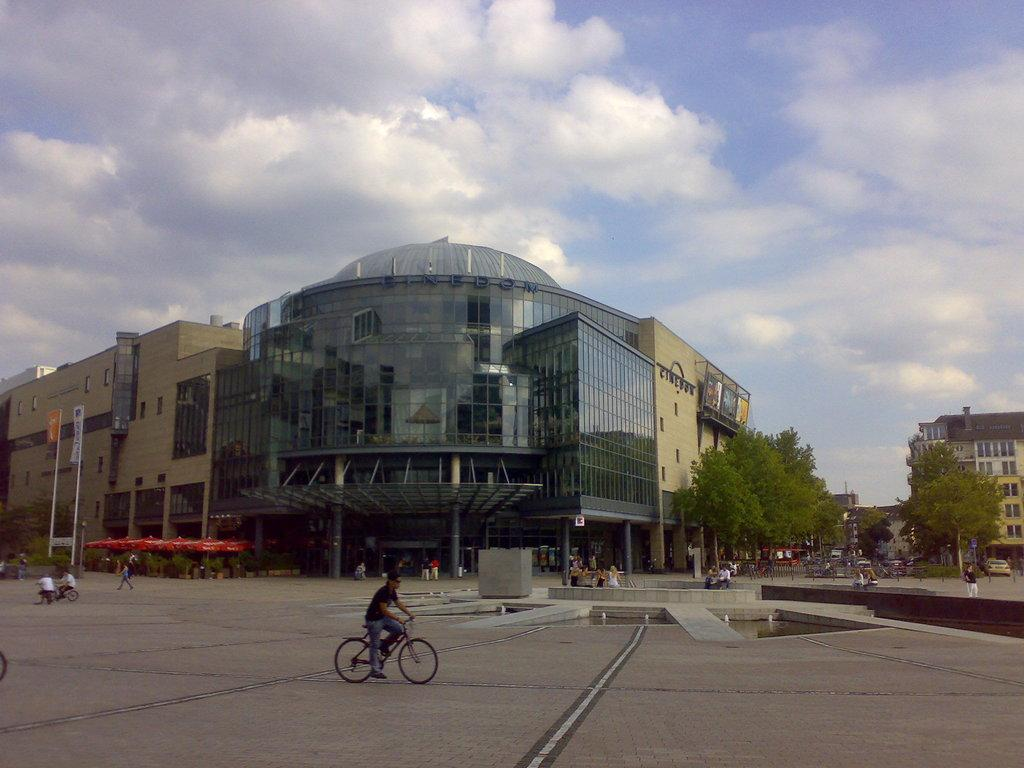What type of structures are visible in the image? There are buildings in the image. What are the people doing in front of the buildings? There are people walking in front of the buildings. Are there any other forms of transportation visible in the image? Yes, there are people riding bicycles in the image. What type of comfort can be found in the argument between the two people in the image? There is no argument or comfort present in the image; it only shows people walking and riding bicycles in front of buildings. 